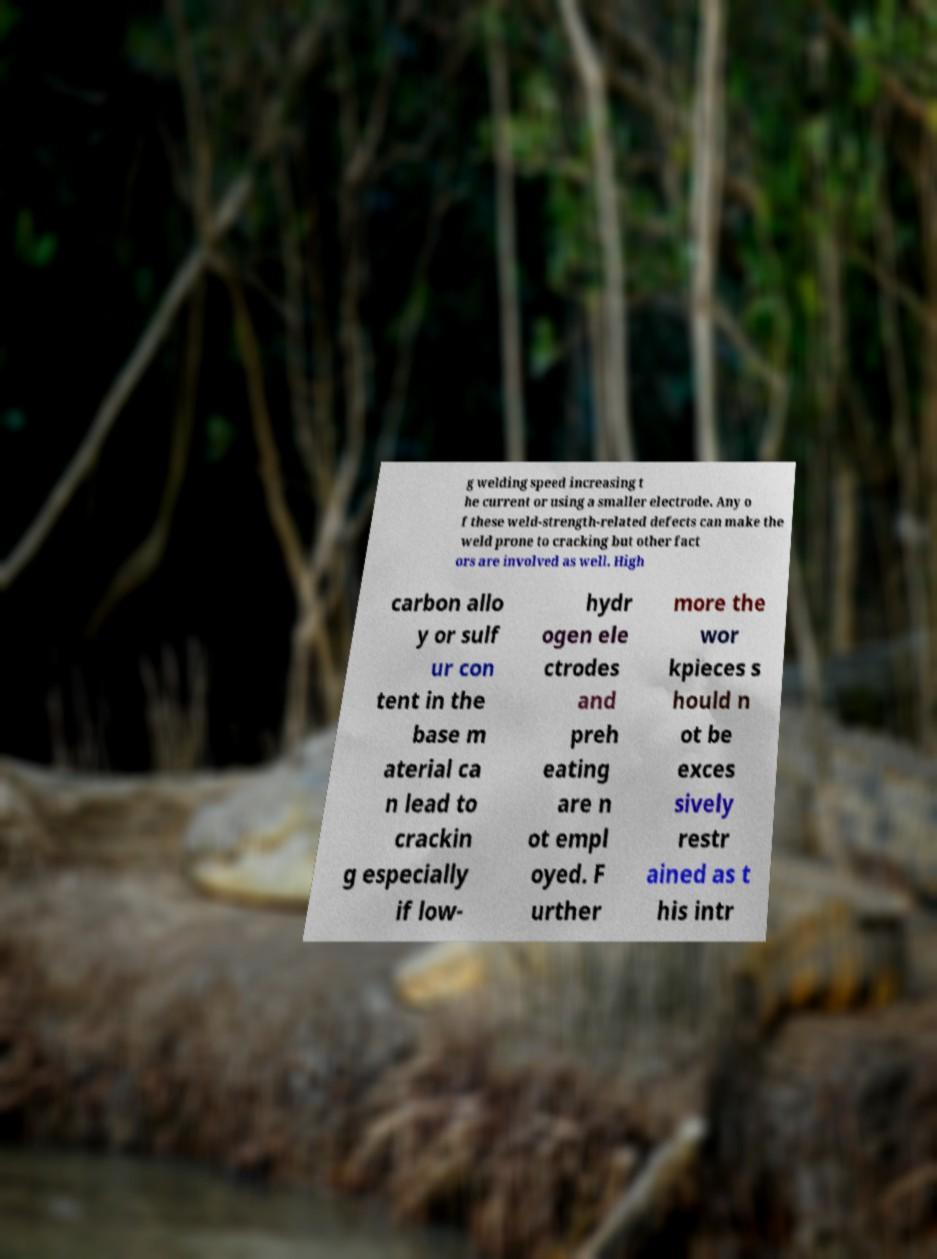Can you accurately transcribe the text from the provided image for me? g welding speed increasing t he current or using a smaller electrode. Any o f these weld-strength-related defects can make the weld prone to cracking but other fact ors are involved as well. High carbon allo y or sulf ur con tent in the base m aterial ca n lead to crackin g especially if low- hydr ogen ele ctrodes and preh eating are n ot empl oyed. F urther more the wor kpieces s hould n ot be exces sively restr ained as t his intr 